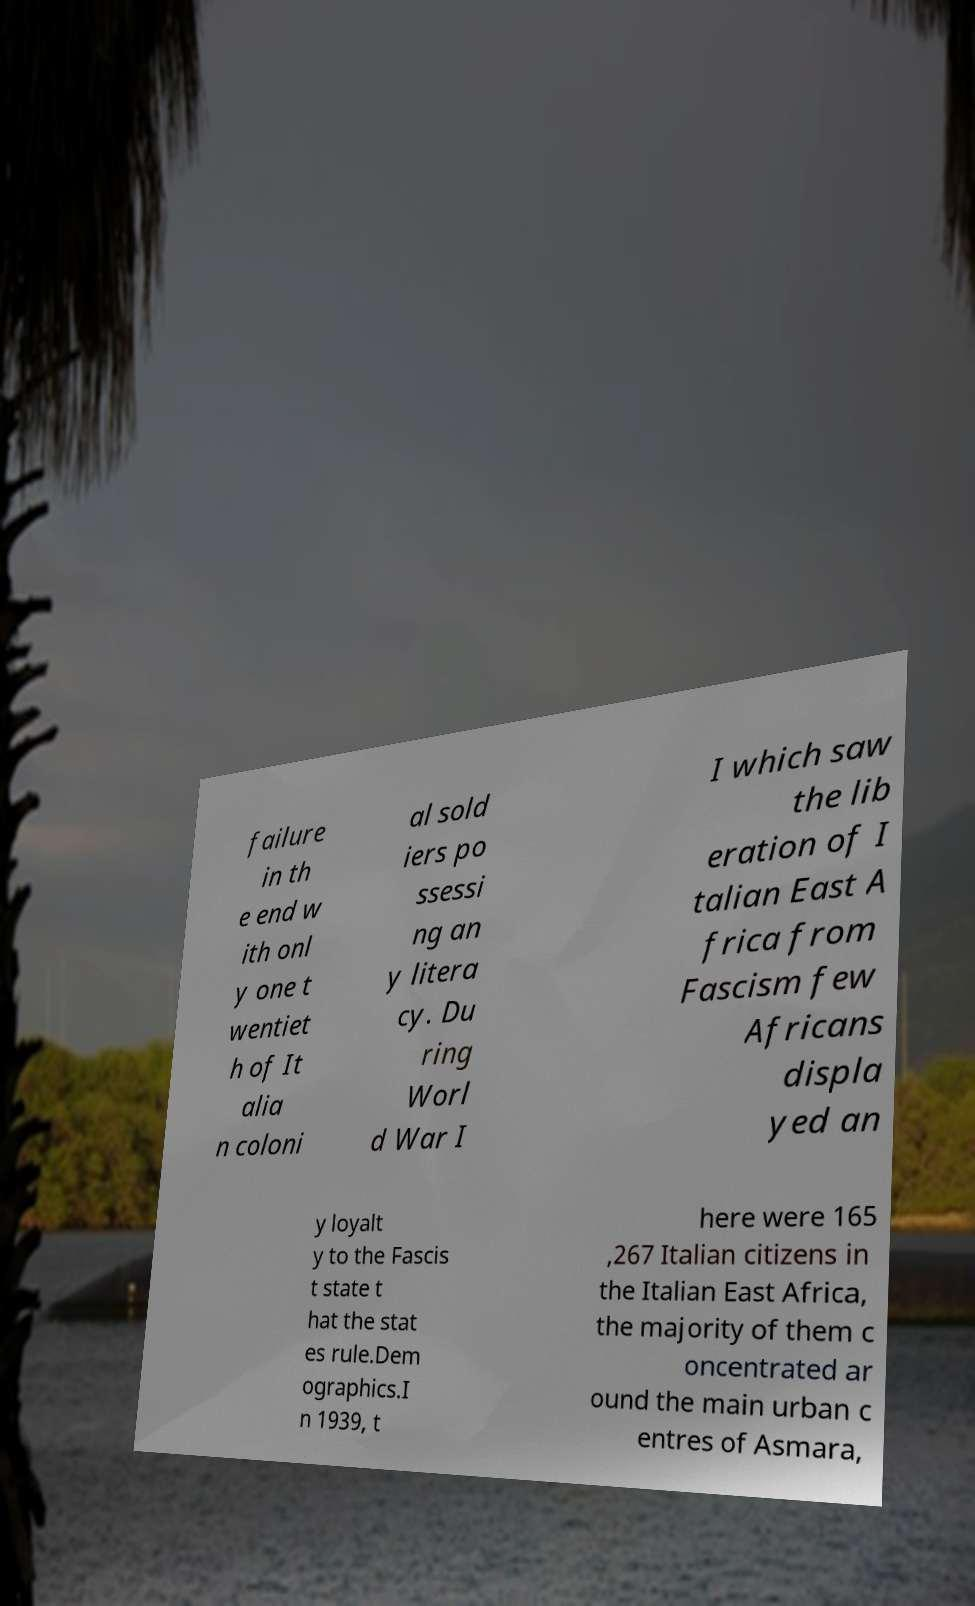There's text embedded in this image that I need extracted. Can you transcribe it verbatim? failure in th e end w ith onl y one t wentiet h of It alia n coloni al sold iers po ssessi ng an y litera cy. Du ring Worl d War I I which saw the lib eration of I talian East A frica from Fascism few Africans displa yed an y loyalt y to the Fascis t state t hat the stat es rule.Dem ographics.I n 1939, t here were 165 ,267 Italian citizens in the Italian East Africa, the majority of them c oncentrated ar ound the main urban c entres of Asmara, 